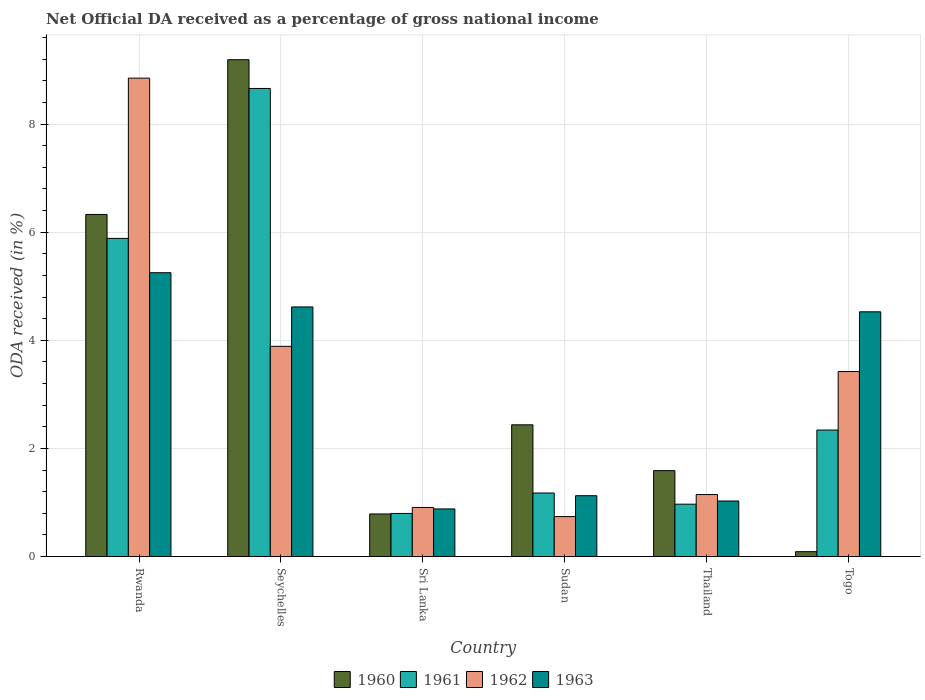How many different coloured bars are there?
Make the answer very short. 4. How many groups of bars are there?
Offer a terse response. 6. Are the number of bars per tick equal to the number of legend labels?
Offer a terse response. Yes. How many bars are there on the 6th tick from the right?
Make the answer very short. 4. What is the label of the 3rd group of bars from the left?
Provide a short and direct response. Sri Lanka. In how many cases, is the number of bars for a given country not equal to the number of legend labels?
Your answer should be compact. 0. What is the net official DA received in 1961 in Thailand?
Provide a short and direct response. 0.97. Across all countries, what is the maximum net official DA received in 1962?
Keep it short and to the point. 8.85. Across all countries, what is the minimum net official DA received in 1960?
Offer a very short reply. 0.09. In which country was the net official DA received in 1963 maximum?
Make the answer very short. Rwanda. In which country was the net official DA received in 1962 minimum?
Your answer should be very brief. Sudan. What is the total net official DA received in 1960 in the graph?
Provide a short and direct response. 20.42. What is the difference between the net official DA received in 1962 in Rwanda and that in Togo?
Provide a short and direct response. 5.43. What is the difference between the net official DA received in 1962 in Sudan and the net official DA received in 1960 in Sri Lanka?
Give a very brief answer. -0.05. What is the average net official DA received in 1963 per country?
Give a very brief answer. 2.91. What is the difference between the net official DA received of/in 1962 and net official DA received of/in 1961 in Seychelles?
Your response must be concise. -4.77. What is the ratio of the net official DA received in 1963 in Seychelles to that in Sudan?
Keep it short and to the point. 4.1. What is the difference between the highest and the second highest net official DA received in 1961?
Ensure brevity in your answer.  6.32. What is the difference between the highest and the lowest net official DA received in 1960?
Give a very brief answer. 9.1. In how many countries, is the net official DA received in 1963 greater than the average net official DA received in 1963 taken over all countries?
Make the answer very short. 3. Is the sum of the net official DA received in 1962 in Sri Lanka and Thailand greater than the maximum net official DA received in 1961 across all countries?
Give a very brief answer. No. What does the 1st bar from the left in Seychelles represents?
Your answer should be very brief. 1960. Is it the case that in every country, the sum of the net official DA received in 1963 and net official DA received in 1962 is greater than the net official DA received in 1960?
Ensure brevity in your answer.  No. How many bars are there?
Provide a short and direct response. 24. How many countries are there in the graph?
Make the answer very short. 6. What is the difference between two consecutive major ticks on the Y-axis?
Your answer should be very brief. 2. Are the values on the major ticks of Y-axis written in scientific E-notation?
Offer a terse response. No. Where does the legend appear in the graph?
Offer a very short reply. Bottom center. What is the title of the graph?
Make the answer very short. Net Official DA received as a percentage of gross national income. Does "2004" appear as one of the legend labels in the graph?
Make the answer very short. No. What is the label or title of the X-axis?
Give a very brief answer. Country. What is the label or title of the Y-axis?
Your answer should be compact. ODA received (in %). What is the ODA received (in %) in 1960 in Rwanda?
Keep it short and to the point. 6.33. What is the ODA received (in %) of 1961 in Rwanda?
Ensure brevity in your answer.  5.89. What is the ODA received (in %) of 1962 in Rwanda?
Make the answer very short. 8.85. What is the ODA received (in %) in 1963 in Rwanda?
Your response must be concise. 5.25. What is the ODA received (in %) in 1960 in Seychelles?
Provide a short and direct response. 9.19. What is the ODA received (in %) of 1961 in Seychelles?
Keep it short and to the point. 8.66. What is the ODA received (in %) of 1962 in Seychelles?
Ensure brevity in your answer.  3.89. What is the ODA received (in %) of 1963 in Seychelles?
Give a very brief answer. 4.62. What is the ODA received (in %) of 1960 in Sri Lanka?
Give a very brief answer. 0.79. What is the ODA received (in %) of 1961 in Sri Lanka?
Offer a very short reply. 0.8. What is the ODA received (in %) in 1962 in Sri Lanka?
Offer a very short reply. 0.91. What is the ODA received (in %) in 1963 in Sri Lanka?
Give a very brief answer. 0.88. What is the ODA received (in %) in 1960 in Sudan?
Your response must be concise. 2.44. What is the ODA received (in %) in 1961 in Sudan?
Provide a succinct answer. 1.18. What is the ODA received (in %) in 1962 in Sudan?
Ensure brevity in your answer.  0.74. What is the ODA received (in %) of 1963 in Sudan?
Keep it short and to the point. 1.13. What is the ODA received (in %) of 1960 in Thailand?
Provide a succinct answer. 1.59. What is the ODA received (in %) in 1961 in Thailand?
Ensure brevity in your answer.  0.97. What is the ODA received (in %) of 1962 in Thailand?
Provide a short and direct response. 1.15. What is the ODA received (in %) of 1963 in Thailand?
Your answer should be very brief. 1.03. What is the ODA received (in %) in 1960 in Togo?
Keep it short and to the point. 0.09. What is the ODA received (in %) of 1961 in Togo?
Offer a very short reply. 2.34. What is the ODA received (in %) in 1962 in Togo?
Your answer should be compact. 3.42. What is the ODA received (in %) of 1963 in Togo?
Give a very brief answer. 4.53. Across all countries, what is the maximum ODA received (in %) in 1960?
Give a very brief answer. 9.19. Across all countries, what is the maximum ODA received (in %) of 1961?
Provide a short and direct response. 8.66. Across all countries, what is the maximum ODA received (in %) of 1962?
Provide a short and direct response. 8.85. Across all countries, what is the maximum ODA received (in %) of 1963?
Make the answer very short. 5.25. Across all countries, what is the minimum ODA received (in %) in 1960?
Make the answer very short. 0.09. Across all countries, what is the minimum ODA received (in %) of 1961?
Provide a succinct answer. 0.8. Across all countries, what is the minimum ODA received (in %) of 1962?
Ensure brevity in your answer.  0.74. Across all countries, what is the minimum ODA received (in %) of 1963?
Provide a short and direct response. 0.88. What is the total ODA received (in %) of 1960 in the graph?
Your answer should be compact. 20.42. What is the total ODA received (in %) of 1961 in the graph?
Give a very brief answer. 19.83. What is the total ODA received (in %) in 1962 in the graph?
Your answer should be very brief. 18.96. What is the total ODA received (in %) of 1963 in the graph?
Offer a very short reply. 17.43. What is the difference between the ODA received (in %) of 1960 in Rwanda and that in Seychelles?
Ensure brevity in your answer.  -2.86. What is the difference between the ODA received (in %) in 1961 in Rwanda and that in Seychelles?
Offer a terse response. -2.77. What is the difference between the ODA received (in %) of 1962 in Rwanda and that in Seychelles?
Offer a very short reply. 4.96. What is the difference between the ODA received (in %) in 1963 in Rwanda and that in Seychelles?
Keep it short and to the point. 0.63. What is the difference between the ODA received (in %) in 1960 in Rwanda and that in Sri Lanka?
Give a very brief answer. 5.54. What is the difference between the ODA received (in %) in 1961 in Rwanda and that in Sri Lanka?
Your answer should be compact. 5.09. What is the difference between the ODA received (in %) in 1962 in Rwanda and that in Sri Lanka?
Keep it short and to the point. 7.94. What is the difference between the ODA received (in %) in 1963 in Rwanda and that in Sri Lanka?
Make the answer very short. 4.37. What is the difference between the ODA received (in %) of 1960 in Rwanda and that in Sudan?
Provide a succinct answer. 3.89. What is the difference between the ODA received (in %) of 1961 in Rwanda and that in Sudan?
Provide a succinct answer. 4.71. What is the difference between the ODA received (in %) in 1962 in Rwanda and that in Sudan?
Provide a succinct answer. 8.11. What is the difference between the ODA received (in %) in 1963 in Rwanda and that in Sudan?
Give a very brief answer. 4.12. What is the difference between the ODA received (in %) of 1960 in Rwanda and that in Thailand?
Offer a terse response. 4.74. What is the difference between the ODA received (in %) of 1961 in Rwanda and that in Thailand?
Offer a terse response. 4.92. What is the difference between the ODA received (in %) in 1962 in Rwanda and that in Thailand?
Offer a very short reply. 7.7. What is the difference between the ODA received (in %) of 1963 in Rwanda and that in Thailand?
Offer a terse response. 4.22. What is the difference between the ODA received (in %) of 1960 in Rwanda and that in Togo?
Your answer should be compact. 6.24. What is the difference between the ODA received (in %) in 1961 in Rwanda and that in Togo?
Offer a very short reply. 3.54. What is the difference between the ODA received (in %) in 1962 in Rwanda and that in Togo?
Offer a very short reply. 5.43. What is the difference between the ODA received (in %) of 1963 in Rwanda and that in Togo?
Your answer should be compact. 0.72. What is the difference between the ODA received (in %) in 1960 in Seychelles and that in Sri Lanka?
Keep it short and to the point. 8.4. What is the difference between the ODA received (in %) in 1961 in Seychelles and that in Sri Lanka?
Your answer should be very brief. 7.86. What is the difference between the ODA received (in %) in 1962 in Seychelles and that in Sri Lanka?
Offer a very short reply. 2.98. What is the difference between the ODA received (in %) in 1963 in Seychelles and that in Sri Lanka?
Offer a very short reply. 3.74. What is the difference between the ODA received (in %) of 1960 in Seychelles and that in Sudan?
Your response must be concise. 6.75. What is the difference between the ODA received (in %) of 1961 in Seychelles and that in Sudan?
Give a very brief answer. 7.48. What is the difference between the ODA received (in %) of 1962 in Seychelles and that in Sudan?
Provide a short and direct response. 3.15. What is the difference between the ODA received (in %) in 1963 in Seychelles and that in Sudan?
Ensure brevity in your answer.  3.49. What is the difference between the ODA received (in %) of 1960 in Seychelles and that in Thailand?
Keep it short and to the point. 7.6. What is the difference between the ODA received (in %) of 1961 in Seychelles and that in Thailand?
Your answer should be very brief. 7.69. What is the difference between the ODA received (in %) in 1962 in Seychelles and that in Thailand?
Ensure brevity in your answer.  2.74. What is the difference between the ODA received (in %) in 1963 in Seychelles and that in Thailand?
Offer a terse response. 3.59. What is the difference between the ODA received (in %) of 1960 in Seychelles and that in Togo?
Provide a succinct answer. 9.1. What is the difference between the ODA received (in %) in 1961 in Seychelles and that in Togo?
Your answer should be compact. 6.32. What is the difference between the ODA received (in %) of 1962 in Seychelles and that in Togo?
Your answer should be compact. 0.47. What is the difference between the ODA received (in %) in 1963 in Seychelles and that in Togo?
Make the answer very short. 0.09. What is the difference between the ODA received (in %) of 1960 in Sri Lanka and that in Sudan?
Offer a terse response. -1.65. What is the difference between the ODA received (in %) in 1961 in Sri Lanka and that in Sudan?
Give a very brief answer. -0.38. What is the difference between the ODA received (in %) of 1962 in Sri Lanka and that in Sudan?
Keep it short and to the point. 0.17. What is the difference between the ODA received (in %) in 1963 in Sri Lanka and that in Sudan?
Your answer should be very brief. -0.24. What is the difference between the ODA received (in %) of 1960 in Sri Lanka and that in Thailand?
Your answer should be very brief. -0.8. What is the difference between the ODA received (in %) in 1961 in Sri Lanka and that in Thailand?
Offer a very short reply. -0.17. What is the difference between the ODA received (in %) in 1962 in Sri Lanka and that in Thailand?
Give a very brief answer. -0.24. What is the difference between the ODA received (in %) of 1963 in Sri Lanka and that in Thailand?
Provide a succinct answer. -0.15. What is the difference between the ODA received (in %) in 1960 in Sri Lanka and that in Togo?
Provide a succinct answer. 0.7. What is the difference between the ODA received (in %) of 1961 in Sri Lanka and that in Togo?
Offer a terse response. -1.54. What is the difference between the ODA received (in %) of 1962 in Sri Lanka and that in Togo?
Your response must be concise. -2.51. What is the difference between the ODA received (in %) of 1963 in Sri Lanka and that in Togo?
Provide a short and direct response. -3.65. What is the difference between the ODA received (in %) of 1960 in Sudan and that in Thailand?
Provide a succinct answer. 0.85. What is the difference between the ODA received (in %) of 1961 in Sudan and that in Thailand?
Your response must be concise. 0.21. What is the difference between the ODA received (in %) of 1962 in Sudan and that in Thailand?
Make the answer very short. -0.41. What is the difference between the ODA received (in %) of 1963 in Sudan and that in Thailand?
Your answer should be compact. 0.1. What is the difference between the ODA received (in %) of 1960 in Sudan and that in Togo?
Make the answer very short. 2.35. What is the difference between the ODA received (in %) in 1961 in Sudan and that in Togo?
Provide a succinct answer. -1.16. What is the difference between the ODA received (in %) in 1962 in Sudan and that in Togo?
Ensure brevity in your answer.  -2.68. What is the difference between the ODA received (in %) in 1963 in Sudan and that in Togo?
Your answer should be compact. -3.4. What is the difference between the ODA received (in %) in 1960 in Thailand and that in Togo?
Your answer should be compact. 1.5. What is the difference between the ODA received (in %) of 1961 in Thailand and that in Togo?
Your answer should be very brief. -1.37. What is the difference between the ODA received (in %) in 1962 in Thailand and that in Togo?
Your answer should be very brief. -2.27. What is the difference between the ODA received (in %) of 1963 in Thailand and that in Togo?
Offer a terse response. -3.5. What is the difference between the ODA received (in %) of 1960 in Rwanda and the ODA received (in %) of 1961 in Seychelles?
Give a very brief answer. -2.33. What is the difference between the ODA received (in %) in 1960 in Rwanda and the ODA received (in %) in 1962 in Seychelles?
Make the answer very short. 2.44. What is the difference between the ODA received (in %) of 1960 in Rwanda and the ODA received (in %) of 1963 in Seychelles?
Offer a terse response. 1.71. What is the difference between the ODA received (in %) in 1961 in Rwanda and the ODA received (in %) in 1962 in Seychelles?
Your answer should be compact. 2. What is the difference between the ODA received (in %) of 1961 in Rwanda and the ODA received (in %) of 1963 in Seychelles?
Your answer should be compact. 1.27. What is the difference between the ODA received (in %) of 1962 in Rwanda and the ODA received (in %) of 1963 in Seychelles?
Give a very brief answer. 4.23. What is the difference between the ODA received (in %) in 1960 in Rwanda and the ODA received (in %) in 1961 in Sri Lanka?
Ensure brevity in your answer.  5.53. What is the difference between the ODA received (in %) of 1960 in Rwanda and the ODA received (in %) of 1962 in Sri Lanka?
Make the answer very short. 5.42. What is the difference between the ODA received (in %) in 1960 in Rwanda and the ODA received (in %) in 1963 in Sri Lanka?
Offer a terse response. 5.45. What is the difference between the ODA received (in %) in 1961 in Rwanda and the ODA received (in %) in 1962 in Sri Lanka?
Provide a short and direct response. 4.98. What is the difference between the ODA received (in %) of 1961 in Rwanda and the ODA received (in %) of 1963 in Sri Lanka?
Your response must be concise. 5. What is the difference between the ODA received (in %) of 1962 in Rwanda and the ODA received (in %) of 1963 in Sri Lanka?
Make the answer very short. 7.97. What is the difference between the ODA received (in %) of 1960 in Rwanda and the ODA received (in %) of 1961 in Sudan?
Make the answer very short. 5.15. What is the difference between the ODA received (in %) of 1960 in Rwanda and the ODA received (in %) of 1962 in Sudan?
Ensure brevity in your answer.  5.59. What is the difference between the ODA received (in %) in 1960 in Rwanda and the ODA received (in %) in 1963 in Sudan?
Your response must be concise. 5.2. What is the difference between the ODA received (in %) in 1961 in Rwanda and the ODA received (in %) in 1962 in Sudan?
Your response must be concise. 5.15. What is the difference between the ODA received (in %) in 1961 in Rwanda and the ODA received (in %) in 1963 in Sudan?
Your answer should be very brief. 4.76. What is the difference between the ODA received (in %) in 1962 in Rwanda and the ODA received (in %) in 1963 in Sudan?
Your response must be concise. 7.72. What is the difference between the ODA received (in %) in 1960 in Rwanda and the ODA received (in %) in 1961 in Thailand?
Offer a terse response. 5.36. What is the difference between the ODA received (in %) in 1960 in Rwanda and the ODA received (in %) in 1962 in Thailand?
Your answer should be compact. 5.18. What is the difference between the ODA received (in %) in 1960 in Rwanda and the ODA received (in %) in 1963 in Thailand?
Give a very brief answer. 5.3. What is the difference between the ODA received (in %) in 1961 in Rwanda and the ODA received (in %) in 1962 in Thailand?
Your answer should be very brief. 4.74. What is the difference between the ODA received (in %) of 1961 in Rwanda and the ODA received (in %) of 1963 in Thailand?
Offer a terse response. 4.86. What is the difference between the ODA received (in %) of 1962 in Rwanda and the ODA received (in %) of 1963 in Thailand?
Make the answer very short. 7.82. What is the difference between the ODA received (in %) of 1960 in Rwanda and the ODA received (in %) of 1961 in Togo?
Offer a very short reply. 3.99. What is the difference between the ODA received (in %) in 1960 in Rwanda and the ODA received (in %) in 1962 in Togo?
Give a very brief answer. 2.91. What is the difference between the ODA received (in %) of 1960 in Rwanda and the ODA received (in %) of 1963 in Togo?
Your response must be concise. 1.8. What is the difference between the ODA received (in %) in 1961 in Rwanda and the ODA received (in %) in 1962 in Togo?
Your answer should be compact. 2.46. What is the difference between the ODA received (in %) in 1961 in Rwanda and the ODA received (in %) in 1963 in Togo?
Your response must be concise. 1.36. What is the difference between the ODA received (in %) of 1962 in Rwanda and the ODA received (in %) of 1963 in Togo?
Your response must be concise. 4.32. What is the difference between the ODA received (in %) in 1960 in Seychelles and the ODA received (in %) in 1961 in Sri Lanka?
Offer a very short reply. 8.39. What is the difference between the ODA received (in %) of 1960 in Seychelles and the ODA received (in %) of 1962 in Sri Lanka?
Your answer should be very brief. 8.28. What is the difference between the ODA received (in %) in 1960 in Seychelles and the ODA received (in %) in 1963 in Sri Lanka?
Keep it short and to the point. 8.31. What is the difference between the ODA received (in %) in 1961 in Seychelles and the ODA received (in %) in 1962 in Sri Lanka?
Offer a very short reply. 7.75. What is the difference between the ODA received (in %) in 1961 in Seychelles and the ODA received (in %) in 1963 in Sri Lanka?
Make the answer very short. 7.78. What is the difference between the ODA received (in %) in 1962 in Seychelles and the ODA received (in %) in 1963 in Sri Lanka?
Offer a very short reply. 3.01. What is the difference between the ODA received (in %) in 1960 in Seychelles and the ODA received (in %) in 1961 in Sudan?
Give a very brief answer. 8.01. What is the difference between the ODA received (in %) in 1960 in Seychelles and the ODA received (in %) in 1962 in Sudan?
Provide a succinct answer. 8.45. What is the difference between the ODA received (in %) of 1960 in Seychelles and the ODA received (in %) of 1963 in Sudan?
Provide a succinct answer. 8.06. What is the difference between the ODA received (in %) of 1961 in Seychelles and the ODA received (in %) of 1962 in Sudan?
Provide a short and direct response. 7.92. What is the difference between the ODA received (in %) in 1961 in Seychelles and the ODA received (in %) in 1963 in Sudan?
Keep it short and to the point. 7.53. What is the difference between the ODA received (in %) of 1962 in Seychelles and the ODA received (in %) of 1963 in Sudan?
Your answer should be very brief. 2.76. What is the difference between the ODA received (in %) in 1960 in Seychelles and the ODA received (in %) in 1961 in Thailand?
Your answer should be very brief. 8.22. What is the difference between the ODA received (in %) of 1960 in Seychelles and the ODA received (in %) of 1962 in Thailand?
Keep it short and to the point. 8.04. What is the difference between the ODA received (in %) of 1960 in Seychelles and the ODA received (in %) of 1963 in Thailand?
Offer a terse response. 8.16. What is the difference between the ODA received (in %) of 1961 in Seychelles and the ODA received (in %) of 1962 in Thailand?
Provide a succinct answer. 7.51. What is the difference between the ODA received (in %) in 1961 in Seychelles and the ODA received (in %) in 1963 in Thailand?
Provide a succinct answer. 7.63. What is the difference between the ODA received (in %) of 1962 in Seychelles and the ODA received (in %) of 1963 in Thailand?
Your answer should be very brief. 2.86. What is the difference between the ODA received (in %) in 1960 in Seychelles and the ODA received (in %) in 1961 in Togo?
Make the answer very short. 6.85. What is the difference between the ODA received (in %) of 1960 in Seychelles and the ODA received (in %) of 1962 in Togo?
Provide a short and direct response. 5.77. What is the difference between the ODA received (in %) in 1960 in Seychelles and the ODA received (in %) in 1963 in Togo?
Give a very brief answer. 4.66. What is the difference between the ODA received (in %) in 1961 in Seychelles and the ODA received (in %) in 1962 in Togo?
Ensure brevity in your answer.  5.24. What is the difference between the ODA received (in %) of 1961 in Seychelles and the ODA received (in %) of 1963 in Togo?
Make the answer very short. 4.13. What is the difference between the ODA received (in %) in 1962 in Seychelles and the ODA received (in %) in 1963 in Togo?
Offer a very short reply. -0.64. What is the difference between the ODA received (in %) of 1960 in Sri Lanka and the ODA received (in %) of 1961 in Sudan?
Your answer should be very brief. -0.39. What is the difference between the ODA received (in %) of 1960 in Sri Lanka and the ODA received (in %) of 1962 in Sudan?
Keep it short and to the point. 0.05. What is the difference between the ODA received (in %) of 1960 in Sri Lanka and the ODA received (in %) of 1963 in Sudan?
Your answer should be very brief. -0.34. What is the difference between the ODA received (in %) in 1961 in Sri Lanka and the ODA received (in %) in 1962 in Sudan?
Ensure brevity in your answer.  0.06. What is the difference between the ODA received (in %) in 1961 in Sri Lanka and the ODA received (in %) in 1963 in Sudan?
Make the answer very short. -0.33. What is the difference between the ODA received (in %) in 1962 in Sri Lanka and the ODA received (in %) in 1963 in Sudan?
Your answer should be compact. -0.22. What is the difference between the ODA received (in %) in 1960 in Sri Lanka and the ODA received (in %) in 1961 in Thailand?
Provide a succinct answer. -0.18. What is the difference between the ODA received (in %) in 1960 in Sri Lanka and the ODA received (in %) in 1962 in Thailand?
Your answer should be compact. -0.36. What is the difference between the ODA received (in %) of 1960 in Sri Lanka and the ODA received (in %) of 1963 in Thailand?
Your answer should be very brief. -0.24. What is the difference between the ODA received (in %) in 1961 in Sri Lanka and the ODA received (in %) in 1962 in Thailand?
Keep it short and to the point. -0.35. What is the difference between the ODA received (in %) in 1961 in Sri Lanka and the ODA received (in %) in 1963 in Thailand?
Your answer should be very brief. -0.23. What is the difference between the ODA received (in %) in 1962 in Sri Lanka and the ODA received (in %) in 1963 in Thailand?
Ensure brevity in your answer.  -0.12. What is the difference between the ODA received (in %) in 1960 in Sri Lanka and the ODA received (in %) in 1961 in Togo?
Your answer should be very brief. -1.55. What is the difference between the ODA received (in %) in 1960 in Sri Lanka and the ODA received (in %) in 1962 in Togo?
Give a very brief answer. -2.63. What is the difference between the ODA received (in %) of 1960 in Sri Lanka and the ODA received (in %) of 1963 in Togo?
Offer a very short reply. -3.74. What is the difference between the ODA received (in %) of 1961 in Sri Lanka and the ODA received (in %) of 1962 in Togo?
Keep it short and to the point. -2.62. What is the difference between the ODA received (in %) of 1961 in Sri Lanka and the ODA received (in %) of 1963 in Togo?
Keep it short and to the point. -3.73. What is the difference between the ODA received (in %) in 1962 in Sri Lanka and the ODA received (in %) in 1963 in Togo?
Ensure brevity in your answer.  -3.62. What is the difference between the ODA received (in %) in 1960 in Sudan and the ODA received (in %) in 1961 in Thailand?
Make the answer very short. 1.47. What is the difference between the ODA received (in %) of 1960 in Sudan and the ODA received (in %) of 1962 in Thailand?
Provide a short and direct response. 1.29. What is the difference between the ODA received (in %) of 1960 in Sudan and the ODA received (in %) of 1963 in Thailand?
Make the answer very short. 1.41. What is the difference between the ODA received (in %) in 1961 in Sudan and the ODA received (in %) in 1962 in Thailand?
Ensure brevity in your answer.  0.03. What is the difference between the ODA received (in %) in 1961 in Sudan and the ODA received (in %) in 1963 in Thailand?
Keep it short and to the point. 0.15. What is the difference between the ODA received (in %) of 1962 in Sudan and the ODA received (in %) of 1963 in Thailand?
Make the answer very short. -0.29. What is the difference between the ODA received (in %) of 1960 in Sudan and the ODA received (in %) of 1961 in Togo?
Offer a terse response. 0.1. What is the difference between the ODA received (in %) in 1960 in Sudan and the ODA received (in %) in 1962 in Togo?
Your answer should be compact. -0.99. What is the difference between the ODA received (in %) of 1960 in Sudan and the ODA received (in %) of 1963 in Togo?
Your answer should be very brief. -2.09. What is the difference between the ODA received (in %) of 1961 in Sudan and the ODA received (in %) of 1962 in Togo?
Provide a short and direct response. -2.25. What is the difference between the ODA received (in %) in 1961 in Sudan and the ODA received (in %) in 1963 in Togo?
Offer a terse response. -3.35. What is the difference between the ODA received (in %) of 1962 in Sudan and the ODA received (in %) of 1963 in Togo?
Keep it short and to the point. -3.79. What is the difference between the ODA received (in %) in 1960 in Thailand and the ODA received (in %) in 1961 in Togo?
Offer a terse response. -0.75. What is the difference between the ODA received (in %) in 1960 in Thailand and the ODA received (in %) in 1962 in Togo?
Your answer should be compact. -1.83. What is the difference between the ODA received (in %) in 1960 in Thailand and the ODA received (in %) in 1963 in Togo?
Ensure brevity in your answer.  -2.94. What is the difference between the ODA received (in %) in 1961 in Thailand and the ODA received (in %) in 1962 in Togo?
Provide a succinct answer. -2.45. What is the difference between the ODA received (in %) of 1961 in Thailand and the ODA received (in %) of 1963 in Togo?
Provide a short and direct response. -3.56. What is the difference between the ODA received (in %) of 1962 in Thailand and the ODA received (in %) of 1963 in Togo?
Your answer should be very brief. -3.38. What is the average ODA received (in %) of 1960 per country?
Make the answer very short. 3.4. What is the average ODA received (in %) of 1961 per country?
Provide a short and direct response. 3.3. What is the average ODA received (in %) of 1962 per country?
Offer a very short reply. 3.16. What is the average ODA received (in %) of 1963 per country?
Make the answer very short. 2.91. What is the difference between the ODA received (in %) of 1960 and ODA received (in %) of 1961 in Rwanda?
Offer a terse response. 0.44. What is the difference between the ODA received (in %) in 1960 and ODA received (in %) in 1962 in Rwanda?
Offer a very short reply. -2.52. What is the difference between the ODA received (in %) of 1960 and ODA received (in %) of 1963 in Rwanda?
Provide a short and direct response. 1.08. What is the difference between the ODA received (in %) in 1961 and ODA received (in %) in 1962 in Rwanda?
Offer a very short reply. -2.96. What is the difference between the ODA received (in %) in 1961 and ODA received (in %) in 1963 in Rwanda?
Your response must be concise. 0.63. What is the difference between the ODA received (in %) of 1962 and ODA received (in %) of 1963 in Rwanda?
Offer a terse response. 3.6. What is the difference between the ODA received (in %) in 1960 and ODA received (in %) in 1961 in Seychelles?
Ensure brevity in your answer.  0.53. What is the difference between the ODA received (in %) in 1960 and ODA received (in %) in 1962 in Seychelles?
Ensure brevity in your answer.  5.3. What is the difference between the ODA received (in %) of 1960 and ODA received (in %) of 1963 in Seychelles?
Offer a terse response. 4.57. What is the difference between the ODA received (in %) in 1961 and ODA received (in %) in 1962 in Seychelles?
Give a very brief answer. 4.77. What is the difference between the ODA received (in %) of 1961 and ODA received (in %) of 1963 in Seychelles?
Offer a very short reply. 4.04. What is the difference between the ODA received (in %) of 1962 and ODA received (in %) of 1963 in Seychelles?
Provide a short and direct response. -0.73. What is the difference between the ODA received (in %) in 1960 and ODA received (in %) in 1961 in Sri Lanka?
Offer a terse response. -0.01. What is the difference between the ODA received (in %) of 1960 and ODA received (in %) of 1962 in Sri Lanka?
Offer a terse response. -0.12. What is the difference between the ODA received (in %) of 1960 and ODA received (in %) of 1963 in Sri Lanka?
Make the answer very short. -0.09. What is the difference between the ODA received (in %) in 1961 and ODA received (in %) in 1962 in Sri Lanka?
Offer a very short reply. -0.11. What is the difference between the ODA received (in %) of 1961 and ODA received (in %) of 1963 in Sri Lanka?
Your answer should be very brief. -0.08. What is the difference between the ODA received (in %) of 1962 and ODA received (in %) of 1963 in Sri Lanka?
Offer a terse response. 0.03. What is the difference between the ODA received (in %) of 1960 and ODA received (in %) of 1961 in Sudan?
Your response must be concise. 1.26. What is the difference between the ODA received (in %) of 1960 and ODA received (in %) of 1962 in Sudan?
Your answer should be very brief. 1.7. What is the difference between the ODA received (in %) in 1960 and ODA received (in %) in 1963 in Sudan?
Give a very brief answer. 1.31. What is the difference between the ODA received (in %) of 1961 and ODA received (in %) of 1962 in Sudan?
Keep it short and to the point. 0.44. What is the difference between the ODA received (in %) of 1961 and ODA received (in %) of 1963 in Sudan?
Give a very brief answer. 0.05. What is the difference between the ODA received (in %) in 1962 and ODA received (in %) in 1963 in Sudan?
Keep it short and to the point. -0.39. What is the difference between the ODA received (in %) in 1960 and ODA received (in %) in 1961 in Thailand?
Provide a short and direct response. 0.62. What is the difference between the ODA received (in %) of 1960 and ODA received (in %) of 1962 in Thailand?
Provide a succinct answer. 0.44. What is the difference between the ODA received (in %) in 1960 and ODA received (in %) in 1963 in Thailand?
Give a very brief answer. 0.56. What is the difference between the ODA received (in %) of 1961 and ODA received (in %) of 1962 in Thailand?
Your answer should be compact. -0.18. What is the difference between the ODA received (in %) of 1961 and ODA received (in %) of 1963 in Thailand?
Ensure brevity in your answer.  -0.06. What is the difference between the ODA received (in %) in 1962 and ODA received (in %) in 1963 in Thailand?
Your answer should be compact. 0.12. What is the difference between the ODA received (in %) of 1960 and ODA received (in %) of 1961 in Togo?
Your response must be concise. -2.25. What is the difference between the ODA received (in %) in 1960 and ODA received (in %) in 1962 in Togo?
Offer a very short reply. -3.33. What is the difference between the ODA received (in %) in 1960 and ODA received (in %) in 1963 in Togo?
Offer a terse response. -4.44. What is the difference between the ODA received (in %) of 1961 and ODA received (in %) of 1962 in Togo?
Offer a very short reply. -1.08. What is the difference between the ODA received (in %) in 1961 and ODA received (in %) in 1963 in Togo?
Offer a terse response. -2.19. What is the difference between the ODA received (in %) of 1962 and ODA received (in %) of 1963 in Togo?
Provide a short and direct response. -1.1. What is the ratio of the ODA received (in %) of 1960 in Rwanda to that in Seychelles?
Keep it short and to the point. 0.69. What is the ratio of the ODA received (in %) in 1961 in Rwanda to that in Seychelles?
Ensure brevity in your answer.  0.68. What is the ratio of the ODA received (in %) in 1962 in Rwanda to that in Seychelles?
Provide a short and direct response. 2.28. What is the ratio of the ODA received (in %) in 1963 in Rwanda to that in Seychelles?
Give a very brief answer. 1.14. What is the ratio of the ODA received (in %) in 1960 in Rwanda to that in Sri Lanka?
Provide a short and direct response. 8.02. What is the ratio of the ODA received (in %) in 1961 in Rwanda to that in Sri Lanka?
Keep it short and to the point. 7.37. What is the ratio of the ODA received (in %) in 1962 in Rwanda to that in Sri Lanka?
Offer a very short reply. 9.73. What is the ratio of the ODA received (in %) in 1963 in Rwanda to that in Sri Lanka?
Your response must be concise. 5.96. What is the ratio of the ODA received (in %) of 1960 in Rwanda to that in Sudan?
Your answer should be very brief. 2.6. What is the ratio of the ODA received (in %) in 1961 in Rwanda to that in Sudan?
Give a very brief answer. 5. What is the ratio of the ODA received (in %) of 1962 in Rwanda to that in Sudan?
Keep it short and to the point. 11.96. What is the ratio of the ODA received (in %) in 1963 in Rwanda to that in Sudan?
Give a very brief answer. 4.66. What is the ratio of the ODA received (in %) in 1960 in Rwanda to that in Thailand?
Your answer should be very brief. 3.98. What is the ratio of the ODA received (in %) of 1961 in Rwanda to that in Thailand?
Make the answer very short. 6.07. What is the ratio of the ODA received (in %) in 1962 in Rwanda to that in Thailand?
Your response must be concise. 7.71. What is the ratio of the ODA received (in %) in 1963 in Rwanda to that in Thailand?
Keep it short and to the point. 5.11. What is the ratio of the ODA received (in %) of 1960 in Rwanda to that in Togo?
Offer a terse response. 69.4. What is the ratio of the ODA received (in %) in 1961 in Rwanda to that in Togo?
Give a very brief answer. 2.51. What is the ratio of the ODA received (in %) of 1962 in Rwanda to that in Togo?
Offer a very short reply. 2.59. What is the ratio of the ODA received (in %) in 1963 in Rwanda to that in Togo?
Ensure brevity in your answer.  1.16. What is the ratio of the ODA received (in %) of 1960 in Seychelles to that in Sri Lanka?
Your answer should be very brief. 11.65. What is the ratio of the ODA received (in %) in 1961 in Seychelles to that in Sri Lanka?
Ensure brevity in your answer.  10.85. What is the ratio of the ODA received (in %) in 1962 in Seychelles to that in Sri Lanka?
Your answer should be very brief. 4.28. What is the ratio of the ODA received (in %) of 1963 in Seychelles to that in Sri Lanka?
Your answer should be very brief. 5.24. What is the ratio of the ODA received (in %) in 1960 in Seychelles to that in Sudan?
Provide a succinct answer. 3.77. What is the ratio of the ODA received (in %) of 1961 in Seychelles to that in Sudan?
Provide a short and direct response. 7.36. What is the ratio of the ODA received (in %) in 1962 in Seychelles to that in Sudan?
Offer a terse response. 5.26. What is the ratio of the ODA received (in %) in 1963 in Seychelles to that in Sudan?
Your answer should be very brief. 4.1. What is the ratio of the ODA received (in %) in 1960 in Seychelles to that in Thailand?
Keep it short and to the point. 5.78. What is the ratio of the ODA received (in %) in 1961 in Seychelles to that in Thailand?
Give a very brief answer. 8.93. What is the ratio of the ODA received (in %) in 1962 in Seychelles to that in Thailand?
Keep it short and to the point. 3.39. What is the ratio of the ODA received (in %) of 1963 in Seychelles to that in Thailand?
Keep it short and to the point. 4.49. What is the ratio of the ODA received (in %) in 1960 in Seychelles to that in Togo?
Your answer should be very brief. 100.8. What is the ratio of the ODA received (in %) of 1961 in Seychelles to that in Togo?
Offer a terse response. 3.7. What is the ratio of the ODA received (in %) in 1962 in Seychelles to that in Togo?
Your answer should be compact. 1.14. What is the ratio of the ODA received (in %) in 1963 in Seychelles to that in Togo?
Offer a very short reply. 1.02. What is the ratio of the ODA received (in %) of 1960 in Sri Lanka to that in Sudan?
Your answer should be compact. 0.32. What is the ratio of the ODA received (in %) of 1961 in Sri Lanka to that in Sudan?
Your answer should be very brief. 0.68. What is the ratio of the ODA received (in %) in 1962 in Sri Lanka to that in Sudan?
Provide a short and direct response. 1.23. What is the ratio of the ODA received (in %) in 1963 in Sri Lanka to that in Sudan?
Your response must be concise. 0.78. What is the ratio of the ODA received (in %) of 1960 in Sri Lanka to that in Thailand?
Give a very brief answer. 0.5. What is the ratio of the ODA received (in %) in 1961 in Sri Lanka to that in Thailand?
Provide a short and direct response. 0.82. What is the ratio of the ODA received (in %) in 1962 in Sri Lanka to that in Thailand?
Keep it short and to the point. 0.79. What is the ratio of the ODA received (in %) in 1963 in Sri Lanka to that in Thailand?
Keep it short and to the point. 0.86. What is the ratio of the ODA received (in %) of 1960 in Sri Lanka to that in Togo?
Keep it short and to the point. 8.65. What is the ratio of the ODA received (in %) in 1961 in Sri Lanka to that in Togo?
Provide a short and direct response. 0.34. What is the ratio of the ODA received (in %) of 1962 in Sri Lanka to that in Togo?
Offer a very short reply. 0.27. What is the ratio of the ODA received (in %) in 1963 in Sri Lanka to that in Togo?
Give a very brief answer. 0.19. What is the ratio of the ODA received (in %) in 1960 in Sudan to that in Thailand?
Provide a succinct answer. 1.53. What is the ratio of the ODA received (in %) in 1961 in Sudan to that in Thailand?
Give a very brief answer. 1.21. What is the ratio of the ODA received (in %) in 1962 in Sudan to that in Thailand?
Your answer should be compact. 0.64. What is the ratio of the ODA received (in %) of 1963 in Sudan to that in Thailand?
Make the answer very short. 1.1. What is the ratio of the ODA received (in %) in 1960 in Sudan to that in Togo?
Offer a terse response. 26.73. What is the ratio of the ODA received (in %) of 1961 in Sudan to that in Togo?
Give a very brief answer. 0.5. What is the ratio of the ODA received (in %) of 1962 in Sudan to that in Togo?
Your answer should be very brief. 0.22. What is the ratio of the ODA received (in %) in 1963 in Sudan to that in Togo?
Offer a very short reply. 0.25. What is the ratio of the ODA received (in %) of 1960 in Thailand to that in Togo?
Provide a short and direct response. 17.44. What is the ratio of the ODA received (in %) in 1961 in Thailand to that in Togo?
Your answer should be compact. 0.41. What is the ratio of the ODA received (in %) of 1962 in Thailand to that in Togo?
Your response must be concise. 0.34. What is the ratio of the ODA received (in %) of 1963 in Thailand to that in Togo?
Your answer should be compact. 0.23. What is the difference between the highest and the second highest ODA received (in %) of 1960?
Ensure brevity in your answer.  2.86. What is the difference between the highest and the second highest ODA received (in %) of 1961?
Your response must be concise. 2.77. What is the difference between the highest and the second highest ODA received (in %) of 1962?
Your answer should be very brief. 4.96. What is the difference between the highest and the second highest ODA received (in %) in 1963?
Your answer should be very brief. 0.63. What is the difference between the highest and the lowest ODA received (in %) in 1960?
Your answer should be very brief. 9.1. What is the difference between the highest and the lowest ODA received (in %) in 1961?
Offer a very short reply. 7.86. What is the difference between the highest and the lowest ODA received (in %) in 1962?
Provide a succinct answer. 8.11. What is the difference between the highest and the lowest ODA received (in %) of 1963?
Keep it short and to the point. 4.37. 